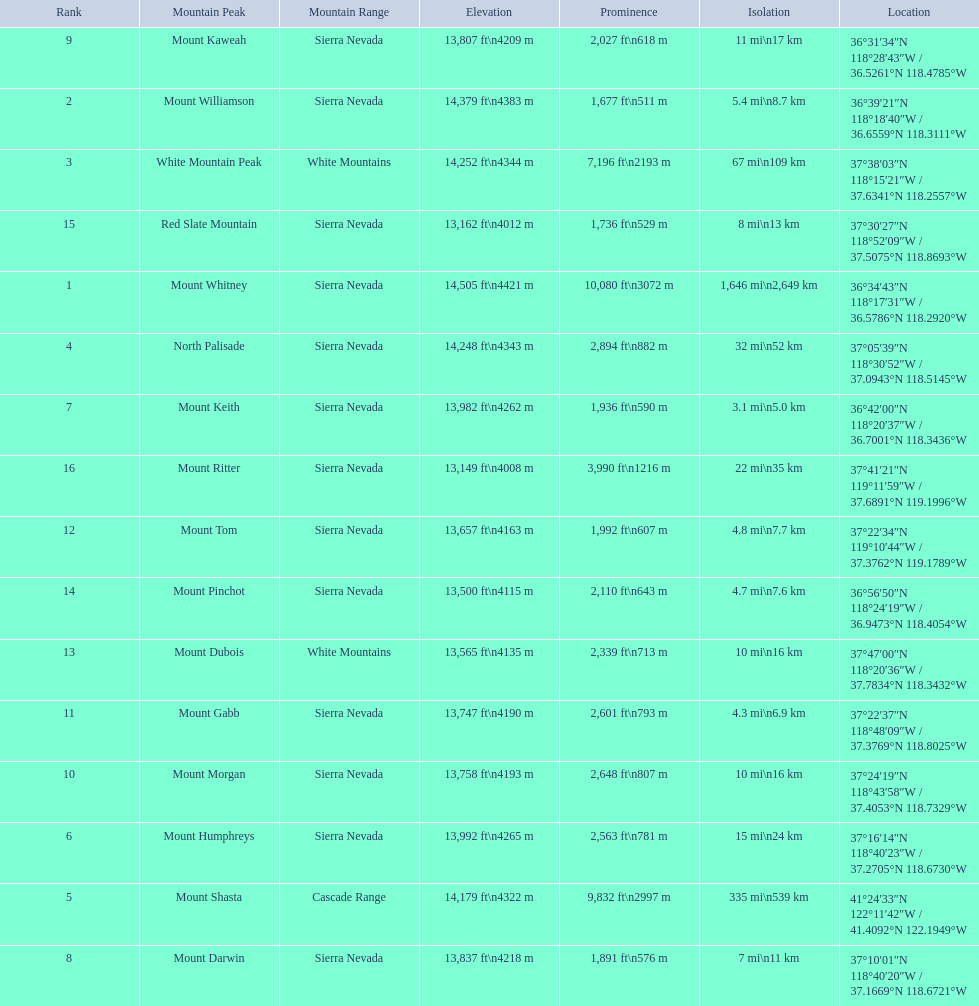Which are the mountain peaks? Mount Whitney, Mount Williamson, White Mountain Peak, North Palisade, Mount Shasta, Mount Humphreys, Mount Keith, Mount Darwin, Mount Kaweah, Mount Morgan, Mount Gabb, Mount Tom, Mount Dubois, Mount Pinchot, Red Slate Mountain, Mount Ritter. Of these, which is in the cascade range? Mount Shasta. 